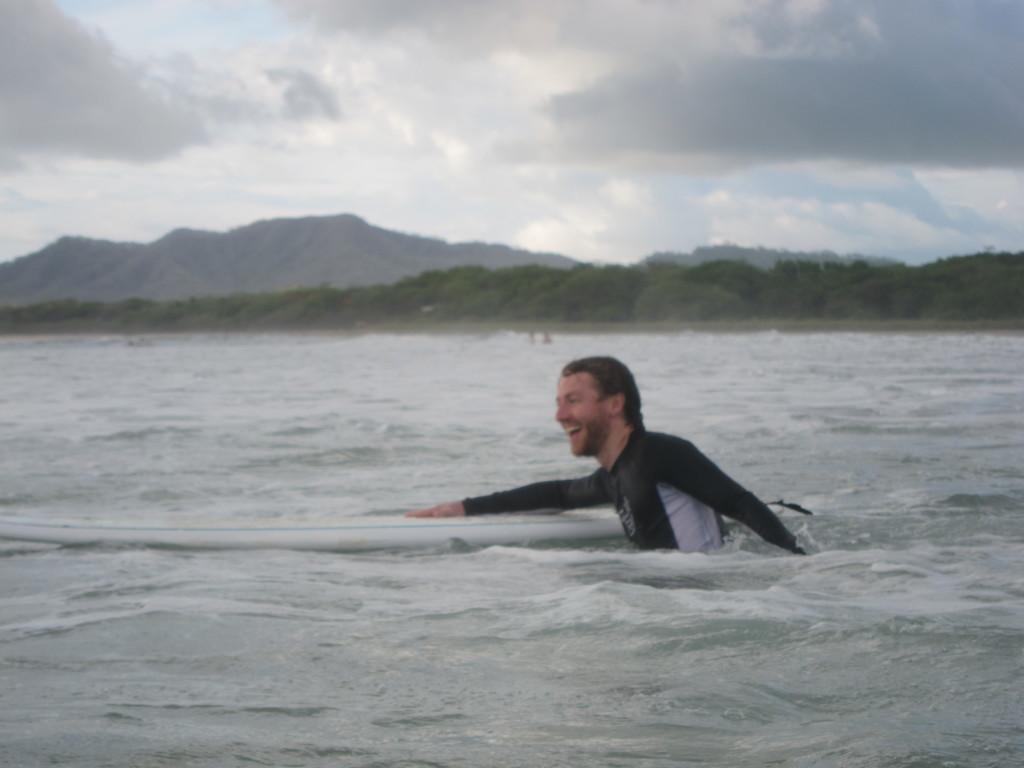In one or two sentences, can you explain what this image depicts? In this image, we can see a person in the water and holding a surfboard. He is smiling. Background we can see trees, hills and cloudy sky. 